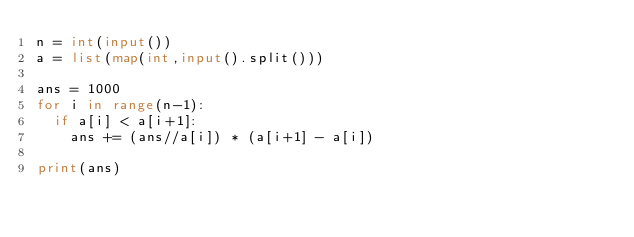Convert code to text. <code><loc_0><loc_0><loc_500><loc_500><_Python_>n = int(input())
a = list(map(int,input().split()))

ans = 1000
for i in range(n-1):
  if a[i] < a[i+1]:
    ans += (ans//a[i]) * (a[i+1] - a[i])
    
print(ans)</code> 